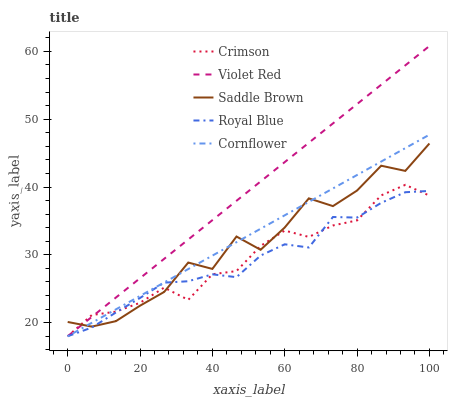Does Royal Blue have the minimum area under the curve?
Answer yes or no. Yes. Does Violet Red have the maximum area under the curve?
Answer yes or no. Yes. Does Violet Red have the minimum area under the curve?
Answer yes or no. No. Does Royal Blue have the maximum area under the curve?
Answer yes or no. No. Is Violet Red the smoothest?
Answer yes or no. Yes. Is Saddle Brown the roughest?
Answer yes or no. Yes. Is Royal Blue the smoothest?
Answer yes or no. No. Is Royal Blue the roughest?
Answer yes or no. No. Does Saddle Brown have the lowest value?
Answer yes or no. No. Does Violet Red have the highest value?
Answer yes or no. Yes. Does Royal Blue have the highest value?
Answer yes or no. No. Does Saddle Brown intersect Cornflower?
Answer yes or no. Yes. Is Saddle Brown less than Cornflower?
Answer yes or no. No. Is Saddle Brown greater than Cornflower?
Answer yes or no. No. 